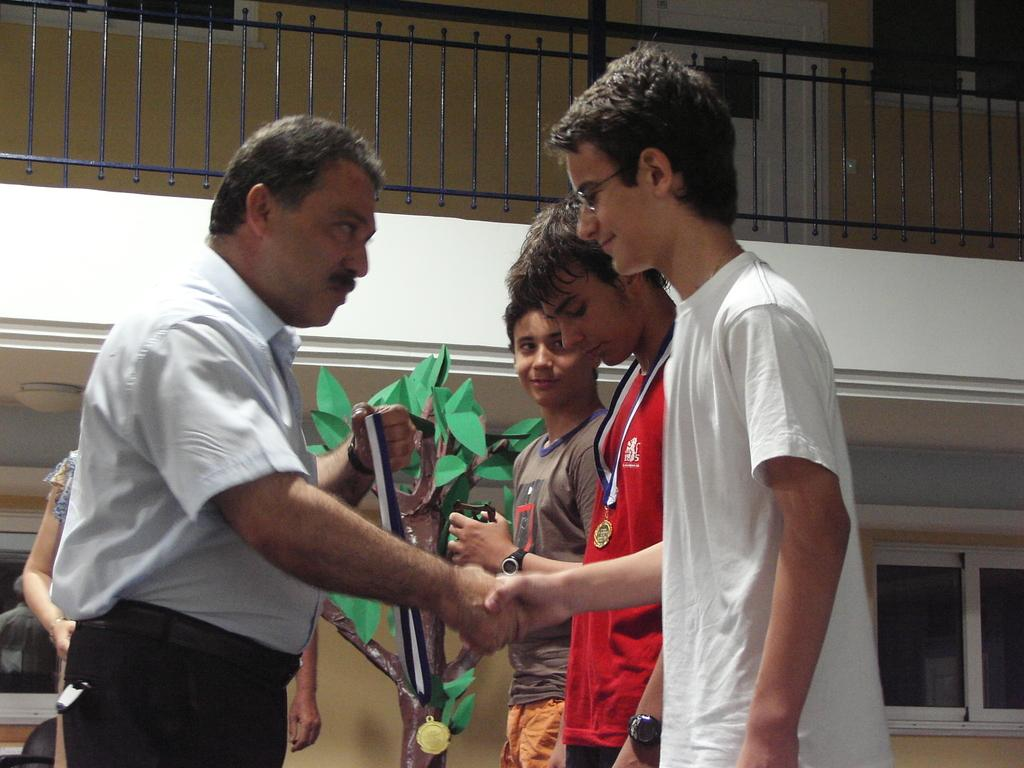How many people are in the image? There are people in the image, but the exact number is not specified. What is the man holding in the image? The man is holding a medal in the image. What can be seen in the background of the image? In the background of the image, there are metal rods and a tree sculpture. What type of hair is the man wearing in the image? There is no mention of hair in the image, so we cannot determine if the man is wearing any. 